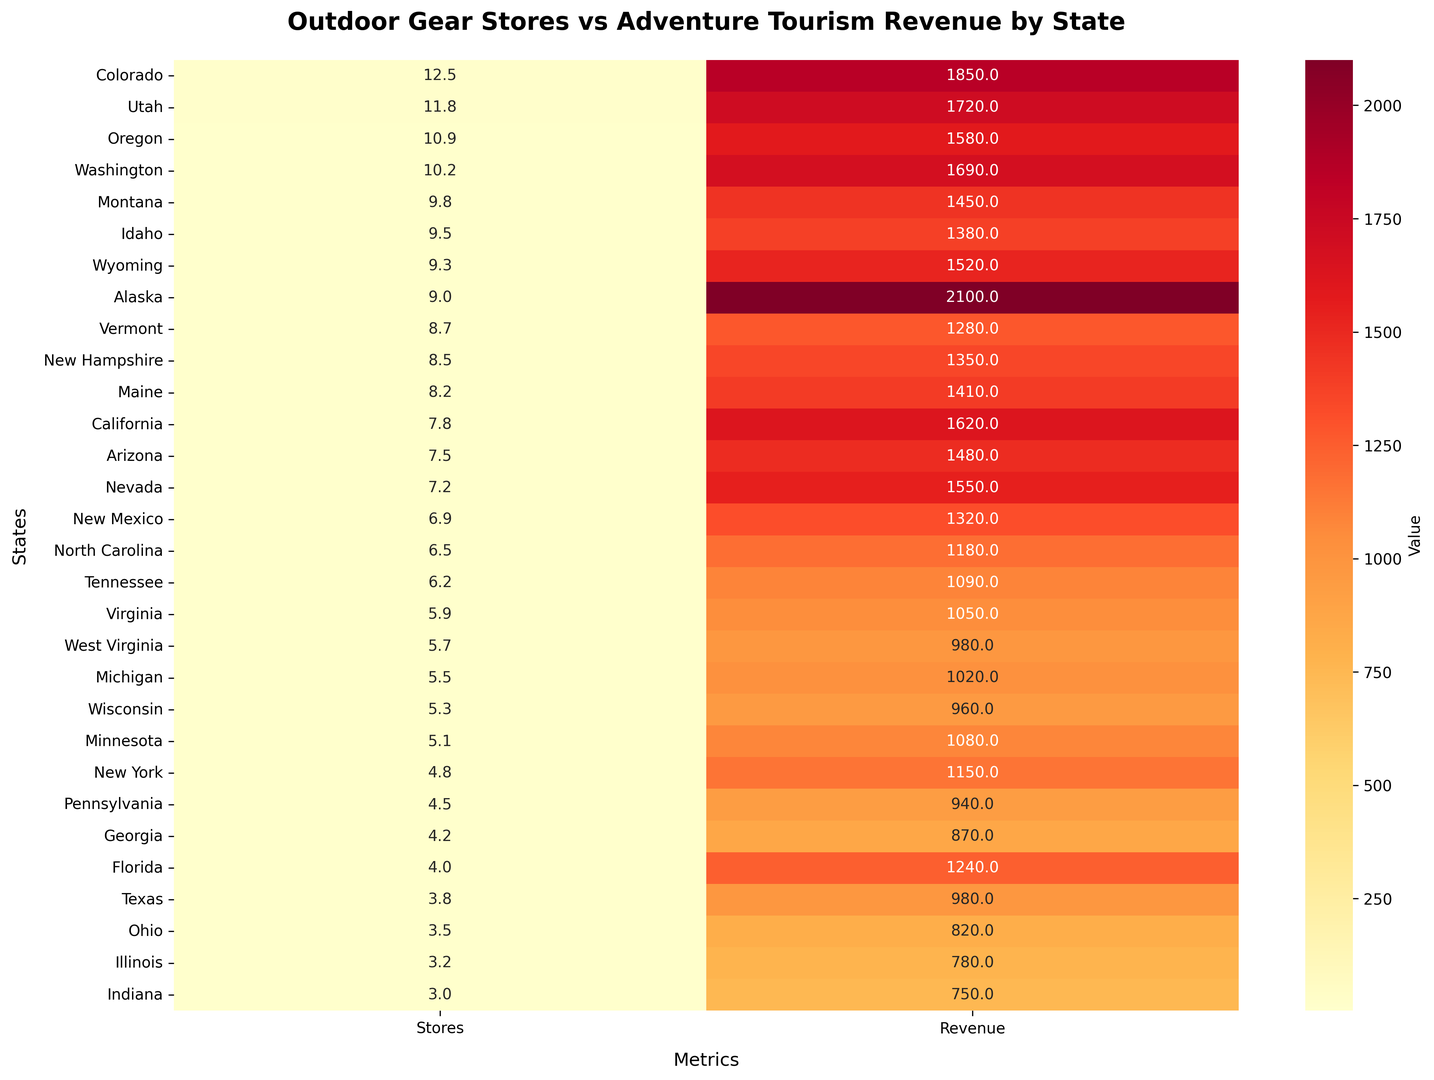Which state has the highest revenue per capita from adventure tourism? The state with the highest value in the "Revenue" column of the heatmap is the state with the highest adventure tourism revenue per capita.
Answer: Alaska How does the number of outdoor gear stores per 100k in Colorado compare to Utah? From the heatmap, Colorado shows 12.5 stores while Utah shows 11.8 stores. Colorado has more stores per 100k people compared to Utah.
Answer: Colorado has more What is the average number of outdoor gear stores per 100k for Montana, Idaho, and Wyoming? Summing the values: 9.8 (Montana) + 9.5 (Idaho) + 9.3 (Wyoming) = 28.6. Average is 28.6/3 = 9.5
Answer: 9.5 Which state has a lower adventure tourism revenue per capita: Virginia or West Virginia? From the heatmap: Virginia has a value of 1050, and West Virginia has a value of 980. Virginia's revenue per capita is higher.
Answer: West Virginia Compare the adventure tourism revenue per capita of Alaska and California. Which is higher? Looking at the heatmap, Alaska has 2100, and California has 1620. Alaska's revenue per capita is higher.
Answer: Alaska What are the cumulative outdoor gear stores per 100k for states with an adventure tourism revenue per capita above 1700? Filter states based on the heatmap values above 1700: Colorado (12.5), Utah (11.8), Alaska (9.0). Sum: 12.5 + 11.8 + 9.0 = 33.3
Answer: 33.3 Which state has the least number of outdoor gear stores per 100k people? The state with the smallest value in the "Stores" column of the heatmap is the state with the least stores per 100k.
Answer: Indiana What color represents the highest adventure tourism revenue per capita in the heatmap? The state with the highest revenue per capita is Alaska (2100), represented by the deepest red in the "Revenue" column.
Answer: Deepest red Is there a consistent color gradient for states with similar outdoor gear store densities? The states with similar densities, such as Montana, Idaho, and Wyoming, have adjacent color shades indicating similar values in the "Stores" column.
Answer: Yes Compare the visual intensity for outdoor gear stores per 100k between North Carolina and Tennessee. North Carolina has a value of 6.5, while Tennessee has 6.2. Both are presented in similar shades of orange, indicating close values.
Answer: Similar 